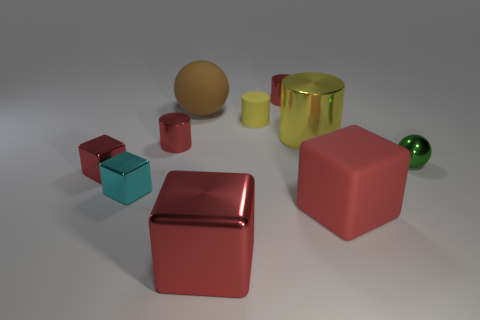Subtract all purple spheres. How many red cubes are left? 3 Subtract 1 cylinders. How many cylinders are left? 3 Subtract all blocks. How many objects are left? 6 Subtract all small shiny blocks. Subtract all big rubber blocks. How many objects are left? 7 Add 9 yellow shiny objects. How many yellow shiny objects are left? 10 Add 7 big green spheres. How many big green spheres exist? 7 Subtract 0 brown cylinders. How many objects are left? 10 